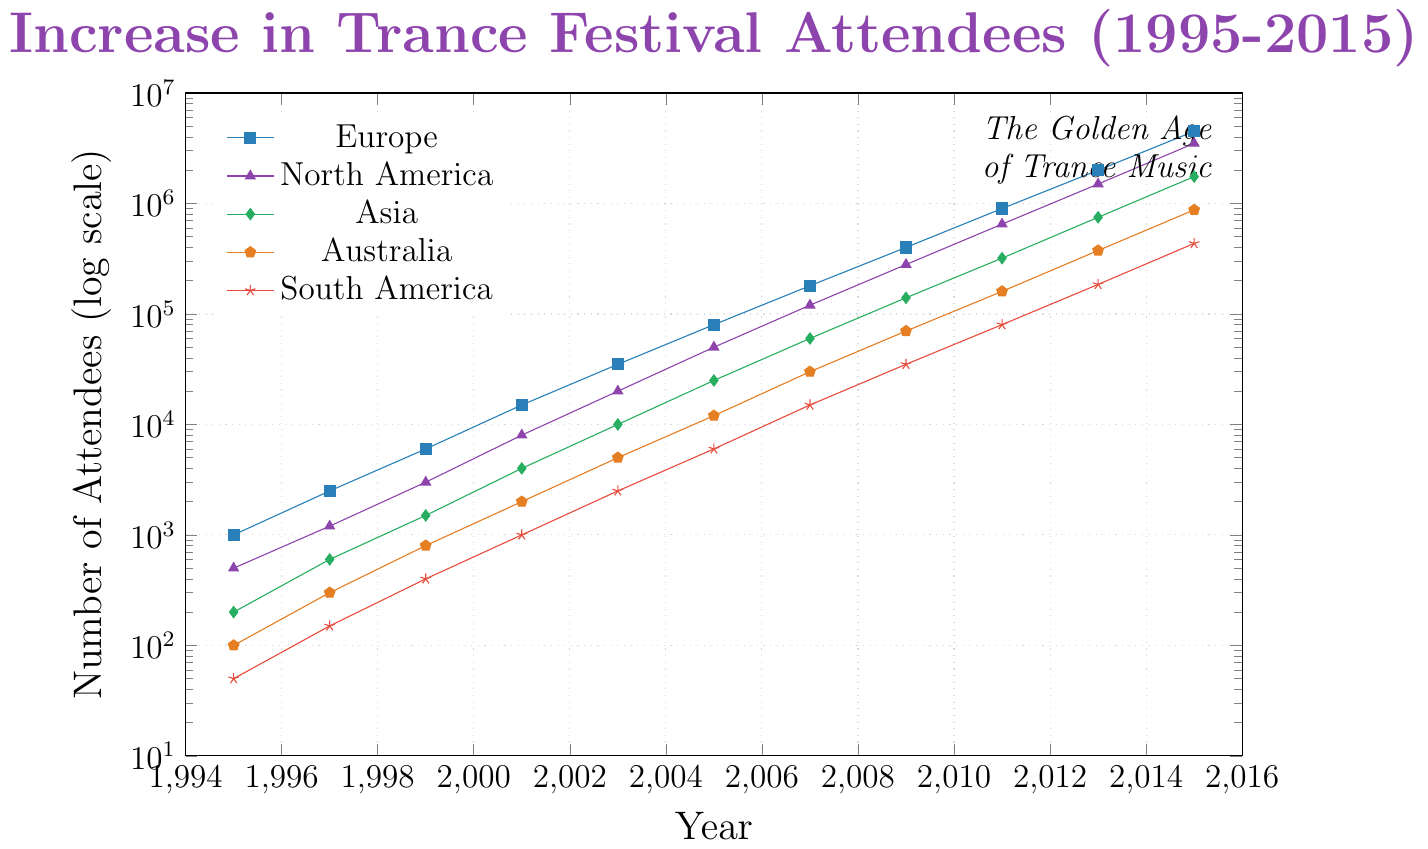What is the general trend of attendees at trance music festivals in Europe from 1995 to 2015? The plot shows a continuous upward trend for Europe, where the number of attendees at trance music festivals increases from 1,000 in 1995 to 4,500,000 in 2015.
Answer: Upward trend Which continent had the steepest growth in attendees from 1995 to 2015? Examine the slopes of the curves for all continents. The North America and Europe curves show the steepest growth, with huge jumps in attendees numbers. Between these two, Europe starts at a higher point in 1995 but North America's growth is also very significant. Comparing the changes, Europe's growth appears slightly steeper overall.
Answer: Europe How did the number of attendees in Asia change from 2001 to 2011? The number of attendees in Asia increases from 4,000 in 2001 to 320,000 in 2011. To verify, check the values at 2001 and 2011 on the curve corresponding to Asia which shows a green line.
Answer: Increased Between which consecutive years did South America have the largest increase in attendees in absolute terms? To find the largest increase, check the differences between years for South America. The largest increase happens between 2013 and 2015, where the attendees rise from 185,000 to 435,000, an increase of 250,000.
Answer: 2013 to 2015 In 2015, which continent had the least number of attendees? By looking at the plot, Asia (green line) has fewer attendees than Europe, North America, and Australia in 2015. South America (red line) is even lower with 435,000 attendees.
Answer: South America What was the attendance ratio between Europe and Australia in 2015? From the plot, in 2015, Europe has 4,500,000 attendees and Australia has 875,000. The ratio is calculated as 4,500,000 / 875,000.
Answer: Approximately 5.14 Which year did North America first surpass 1,000,000 attendees? Look at the curve for North America (purple line) and identify the year when the number of attendees surpasses 1,000,000. The year is 2011.
Answer: 2011 What is the overall shape of the trend for Australia and how does it compare to the trend for Asia? The trend for Australia (orange line) shows consistent exponential growth from 1995 to 2015, similar to Asia (green line). Both show steady climbs, but Australia's growth is slightly slower than Asia’s when comparing overall attendee numbers over the years.
Answer: Similar growth, but slower for Australia What was the average number of attendees at trance festivals in North America and Europe in 2011? For North America in 2011, there are 650,000 attendees and for Europe, there are 900,000. The average is calculated as (650,000 + 900,000) / 2.
Answer: 775,000 How many attendees were there in 2005 on all continents combined? For 2005, sum the attendees from all continents: 80,000 (Europe), 50,000 (North America), 25,000 (Asia), 12,000 (Australia), and 6,000 (South America). The total is 173,000.
Answer: 173,000 